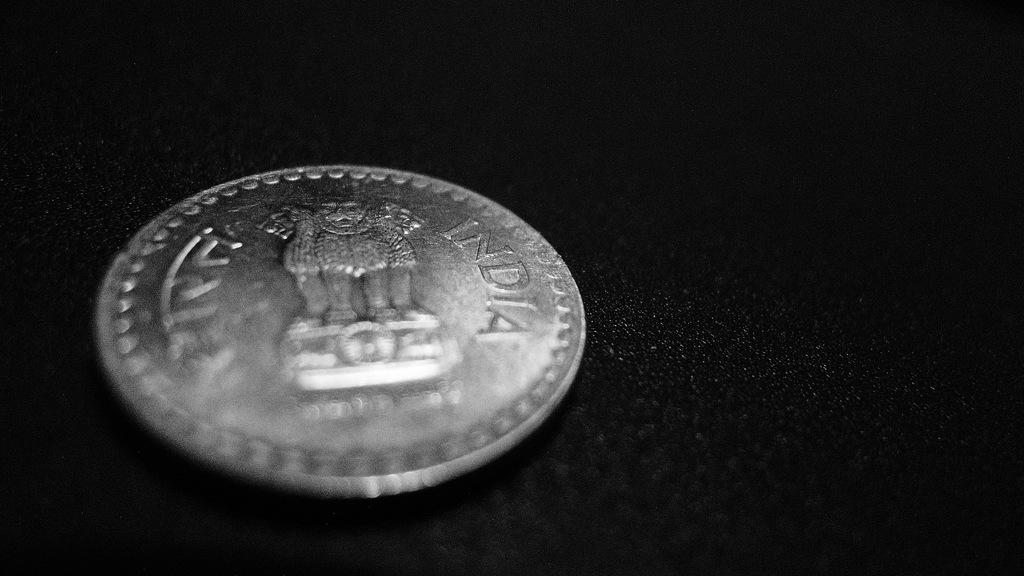<image>
Give a short and clear explanation of the subsequent image. The back of a coin says that it is from India. 